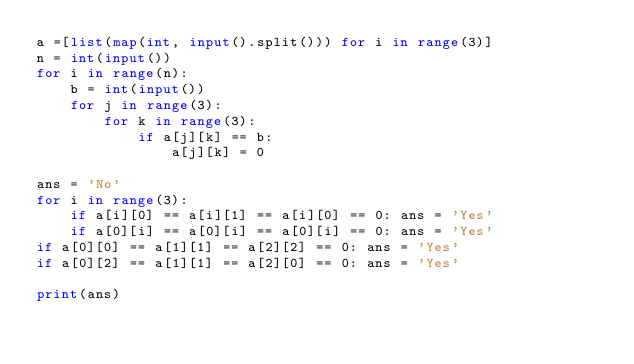Convert code to text. <code><loc_0><loc_0><loc_500><loc_500><_Python_>a =[list(map(int, input().split())) for i in range(3)] 
n = int(input())
for i in range(n):
	b = int(input())
	for j in range(3):
		for k in range(3):
			if a[j][k] == b:
				a[j][k] = 0
				
ans = 'No'
for i in range(3):
	if a[i][0] == a[i][1] == a[i][0] == 0: ans = 'Yes'
	if a[0][i] == a[0][i] == a[0][i] == 0: ans = 'Yes'
if a[0][0] == a[1][1] == a[2][2] == 0: ans = 'Yes'
if a[0][2] == a[1][1] == a[2][0] == 0: ans = 'Yes'
	
print(ans)
	</code> 